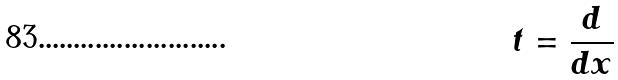Convert formula to latex. <formula><loc_0><loc_0><loc_500><loc_500>t = \frac { d } { d x }</formula> 